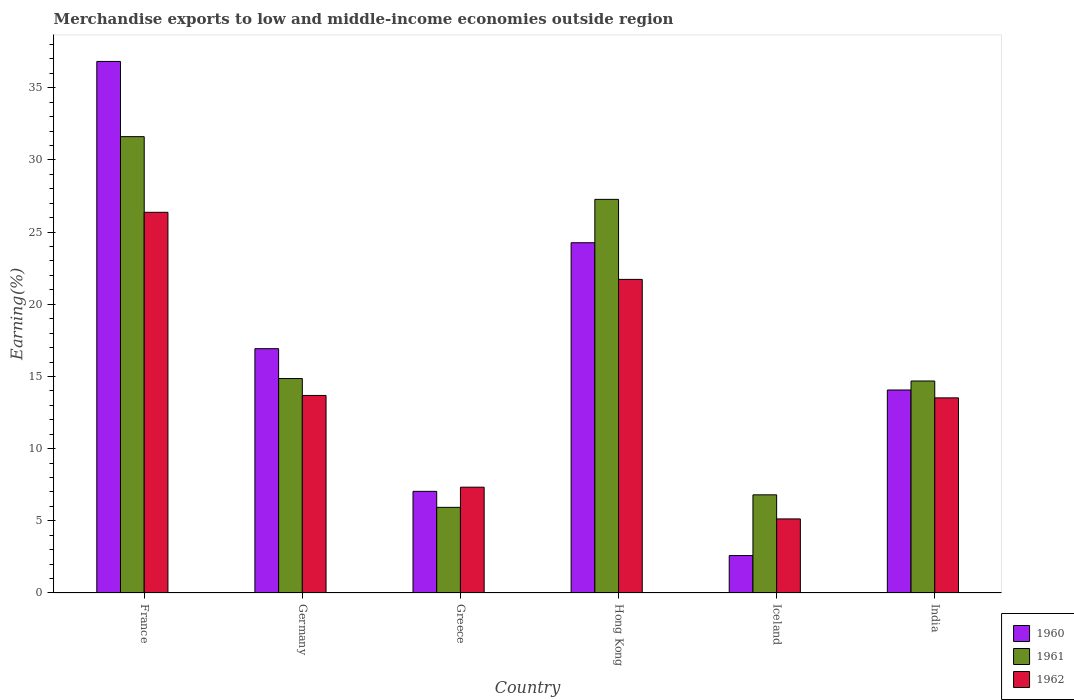How many different coloured bars are there?
Offer a very short reply. 3. How many bars are there on the 2nd tick from the right?
Offer a very short reply. 3. What is the label of the 3rd group of bars from the left?
Provide a short and direct response. Greece. What is the percentage of amount earned from merchandise exports in 1961 in India?
Your answer should be very brief. 14.68. Across all countries, what is the maximum percentage of amount earned from merchandise exports in 1961?
Keep it short and to the point. 31.61. Across all countries, what is the minimum percentage of amount earned from merchandise exports in 1962?
Keep it short and to the point. 5.13. In which country was the percentage of amount earned from merchandise exports in 1960 maximum?
Give a very brief answer. France. In which country was the percentage of amount earned from merchandise exports in 1961 minimum?
Offer a very short reply. Greece. What is the total percentage of amount earned from merchandise exports in 1962 in the graph?
Provide a succinct answer. 87.75. What is the difference between the percentage of amount earned from merchandise exports in 1960 in Iceland and that in India?
Your answer should be compact. -11.47. What is the difference between the percentage of amount earned from merchandise exports in 1960 in Hong Kong and the percentage of amount earned from merchandise exports in 1962 in India?
Give a very brief answer. 10.75. What is the average percentage of amount earned from merchandise exports in 1961 per country?
Offer a terse response. 16.86. What is the difference between the percentage of amount earned from merchandise exports of/in 1961 and percentage of amount earned from merchandise exports of/in 1962 in Hong Kong?
Your answer should be compact. 5.54. What is the ratio of the percentage of amount earned from merchandise exports in 1962 in Germany to that in Greece?
Offer a very short reply. 1.87. Is the percentage of amount earned from merchandise exports in 1962 in Greece less than that in India?
Your answer should be very brief. Yes. Is the difference between the percentage of amount earned from merchandise exports in 1961 in Iceland and India greater than the difference between the percentage of amount earned from merchandise exports in 1962 in Iceland and India?
Provide a succinct answer. Yes. What is the difference between the highest and the second highest percentage of amount earned from merchandise exports in 1962?
Make the answer very short. 12.69. What is the difference between the highest and the lowest percentage of amount earned from merchandise exports in 1960?
Ensure brevity in your answer.  34.23. What does the 2nd bar from the right in Germany represents?
Provide a succinct answer. 1961. Is it the case that in every country, the sum of the percentage of amount earned from merchandise exports in 1961 and percentage of amount earned from merchandise exports in 1962 is greater than the percentage of amount earned from merchandise exports in 1960?
Offer a terse response. Yes. How many countries are there in the graph?
Give a very brief answer. 6. Are the values on the major ticks of Y-axis written in scientific E-notation?
Give a very brief answer. No. Does the graph contain grids?
Provide a short and direct response. No. How many legend labels are there?
Provide a short and direct response. 3. What is the title of the graph?
Your response must be concise. Merchandise exports to low and middle-income economies outside region. Does "1982" appear as one of the legend labels in the graph?
Offer a very short reply. No. What is the label or title of the X-axis?
Provide a succinct answer. Country. What is the label or title of the Y-axis?
Provide a short and direct response. Earning(%). What is the Earning(%) of 1960 in France?
Your response must be concise. 36.82. What is the Earning(%) in 1961 in France?
Your response must be concise. 31.61. What is the Earning(%) of 1962 in France?
Give a very brief answer. 26.37. What is the Earning(%) in 1960 in Germany?
Offer a terse response. 16.92. What is the Earning(%) in 1961 in Germany?
Your answer should be very brief. 14.85. What is the Earning(%) of 1962 in Germany?
Offer a very short reply. 13.68. What is the Earning(%) of 1960 in Greece?
Give a very brief answer. 7.04. What is the Earning(%) of 1961 in Greece?
Offer a terse response. 5.93. What is the Earning(%) in 1962 in Greece?
Provide a short and direct response. 7.33. What is the Earning(%) in 1960 in Hong Kong?
Your response must be concise. 24.26. What is the Earning(%) of 1961 in Hong Kong?
Ensure brevity in your answer.  27.27. What is the Earning(%) of 1962 in Hong Kong?
Ensure brevity in your answer.  21.72. What is the Earning(%) of 1960 in Iceland?
Provide a short and direct response. 2.59. What is the Earning(%) in 1961 in Iceland?
Provide a short and direct response. 6.8. What is the Earning(%) of 1962 in Iceland?
Provide a short and direct response. 5.13. What is the Earning(%) in 1960 in India?
Give a very brief answer. 14.06. What is the Earning(%) in 1961 in India?
Offer a terse response. 14.68. What is the Earning(%) of 1962 in India?
Keep it short and to the point. 13.52. Across all countries, what is the maximum Earning(%) in 1960?
Your response must be concise. 36.82. Across all countries, what is the maximum Earning(%) of 1961?
Your response must be concise. 31.61. Across all countries, what is the maximum Earning(%) of 1962?
Your response must be concise. 26.37. Across all countries, what is the minimum Earning(%) in 1960?
Provide a short and direct response. 2.59. Across all countries, what is the minimum Earning(%) in 1961?
Your response must be concise. 5.93. Across all countries, what is the minimum Earning(%) in 1962?
Your answer should be very brief. 5.13. What is the total Earning(%) in 1960 in the graph?
Keep it short and to the point. 101.7. What is the total Earning(%) in 1961 in the graph?
Provide a short and direct response. 101.15. What is the total Earning(%) of 1962 in the graph?
Your response must be concise. 87.75. What is the difference between the Earning(%) of 1960 in France and that in Germany?
Your answer should be compact. 19.9. What is the difference between the Earning(%) of 1961 in France and that in Germany?
Your answer should be compact. 16.76. What is the difference between the Earning(%) in 1962 in France and that in Germany?
Your answer should be compact. 12.69. What is the difference between the Earning(%) of 1960 in France and that in Greece?
Provide a short and direct response. 29.78. What is the difference between the Earning(%) of 1961 in France and that in Greece?
Offer a very short reply. 25.68. What is the difference between the Earning(%) in 1962 in France and that in Greece?
Provide a short and direct response. 19.04. What is the difference between the Earning(%) of 1960 in France and that in Hong Kong?
Make the answer very short. 12.56. What is the difference between the Earning(%) of 1961 in France and that in Hong Kong?
Provide a short and direct response. 4.34. What is the difference between the Earning(%) of 1962 in France and that in Hong Kong?
Your response must be concise. 4.65. What is the difference between the Earning(%) of 1960 in France and that in Iceland?
Your answer should be very brief. 34.23. What is the difference between the Earning(%) in 1961 in France and that in Iceland?
Provide a succinct answer. 24.81. What is the difference between the Earning(%) in 1962 in France and that in Iceland?
Your answer should be compact. 21.24. What is the difference between the Earning(%) in 1960 in France and that in India?
Provide a succinct answer. 22.76. What is the difference between the Earning(%) in 1961 in France and that in India?
Your response must be concise. 16.93. What is the difference between the Earning(%) in 1962 in France and that in India?
Ensure brevity in your answer.  12.85. What is the difference between the Earning(%) of 1960 in Germany and that in Greece?
Ensure brevity in your answer.  9.88. What is the difference between the Earning(%) in 1961 in Germany and that in Greece?
Make the answer very short. 8.92. What is the difference between the Earning(%) in 1962 in Germany and that in Greece?
Make the answer very short. 6.35. What is the difference between the Earning(%) in 1960 in Germany and that in Hong Kong?
Your response must be concise. -7.34. What is the difference between the Earning(%) of 1961 in Germany and that in Hong Kong?
Ensure brevity in your answer.  -12.41. What is the difference between the Earning(%) in 1962 in Germany and that in Hong Kong?
Offer a very short reply. -8.04. What is the difference between the Earning(%) of 1960 in Germany and that in Iceland?
Ensure brevity in your answer.  14.33. What is the difference between the Earning(%) of 1961 in Germany and that in Iceland?
Keep it short and to the point. 8.05. What is the difference between the Earning(%) in 1962 in Germany and that in Iceland?
Your response must be concise. 8.55. What is the difference between the Earning(%) of 1960 in Germany and that in India?
Provide a succinct answer. 2.86. What is the difference between the Earning(%) in 1961 in Germany and that in India?
Give a very brief answer. 0.17. What is the difference between the Earning(%) of 1962 in Germany and that in India?
Provide a short and direct response. 0.17. What is the difference between the Earning(%) of 1960 in Greece and that in Hong Kong?
Provide a short and direct response. -17.22. What is the difference between the Earning(%) in 1961 in Greece and that in Hong Kong?
Your answer should be compact. -21.33. What is the difference between the Earning(%) of 1962 in Greece and that in Hong Kong?
Provide a succinct answer. -14.39. What is the difference between the Earning(%) in 1960 in Greece and that in Iceland?
Keep it short and to the point. 4.45. What is the difference between the Earning(%) in 1961 in Greece and that in Iceland?
Give a very brief answer. -0.87. What is the difference between the Earning(%) of 1962 in Greece and that in Iceland?
Keep it short and to the point. 2.2. What is the difference between the Earning(%) of 1960 in Greece and that in India?
Your response must be concise. -7.02. What is the difference between the Earning(%) in 1961 in Greece and that in India?
Your answer should be very brief. -8.75. What is the difference between the Earning(%) in 1962 in Greece and that in India?
Keep it short and to the point. -6.19. What is the difference between the Earning(%) in 1960 in Hong Kong and that in Iceland?
Your answer should be compact. 21.67. What is the difference between the Earning(%) of 1961 in Hong Kong and that in Iceland?
Make the answer very short. 20.47. What is the difference between the Earning(%) in 1962 in Hong Kong and that in Iceland?
Offer a terse response. 16.59. What is the difference between the Earning(%) in 1960 in Hong Kong and that in India?
Make the answer very short. 10.2. What is the difference between the Earning(%) in 1961 in Hong Kong and that in India?
Give a very brief answer. 12.58. What is the difference between the Earning(%) of 1962 in Hong Kong and that in India?
Keep it short and to the point. 8.21. What is the difference between the Earning(%) in 1960 in Iceland and that in India?
Keep it short and to the point. -11.47. What is the difference between the Earning(%) of 1961 in Iceland and that in India?
Offer a very short reply. -7.89. What is the difference between the Earning(%) in 1962 in Iceland and that in India?
Offer a terse response. -8.38. What is the difference between the Earning(%) in 1960 in France and the Earning(%) in 1961 in Germany?
Make the answer very short. 21.97. What is the difference between the Earning(%) in 1960 in France and the Earning(%) in 1962 in Germany?
Offer a very short reply. 23.14. What is the difference between the Earning(%) of 1961 in France and the Earning(%) of 1962 in Germany?
Your response must be concise. 17.93. What is the difference between the Earning(%) of 1960 in France and the Earning(%) of 1961 in Greece?
Provide a succinct answer. 30.89. What is the difference between the Earning(%) in 1960 in France and the Earning(%) in 1962 in Greece?
Your response must be concise. 29.49. What is the difference between the Earning(%) of 1961 in France and the Earning(%) of 1962 in Greece?
Provide a short and direct response. 24.28. What is the difference between the Earning(%) of 1960 in France and the Earning(%) of 1961 in Hong Kong?
Make the answer very short. 9.55. What is the difference between the Earning(%) in 1960 in France and the Earning(%) in 1962 in Hong Kong?
Ensure brevity in your answer.  15.1. What is the difference between the Earning(%) in 1961 in France and the Earning(%) in 1962 in Hong Kong?
Make the answer very short. 9.89. What is the difference between the Earning(%) in 1960 in France and the Earning(%) in 1961 in Iceland?
Provide a short and direct response. 30.02. What is the difference between the Earning(%) in 1960 in France and the Earning(%) in 1962 in Iceland?
Keep it short and to the point. 31.69. What is the difference between the Earning(%) in 1961 in France and the Earning(%) in 1962 in Iceland?
Your response must be concise. 26.48. What is the difference between the Earning(%) of 1960 in France and the Earning(%) of 1961 in India?
Offer a terse response. 22.13. What is the difference between the Earning(%) in 1960 in France and the Earning(%) in 1962 in India?
Your answer should be very brief. 23.3. What is the difference between the Earning(%) of 1961 in France and the Earning(%) of 1962 in India?
Your answer should be very brief. 18.09. What is the difference between the Earning(%) in 1960 in Germany and the Earning(%) in 1961 in Greece?
Give a very brief answer. 10.99. What is the difference between the Earning(%) of 1960 in Germany and the Earning(%) of 1962 in Greece?
Give a very brief answer. 9.59. What is the difference between the Earning(%) of 1961 in Germany and the Earning(%) of 1962 in Greece?
Provide a succinct answer. 7.52. What is the difference between the Earning(%) of 1960 in Germany and the Earning(%) of 1961 in Hong Kong?
Ensure brevity in your answer.  -10.34. What is the difference between the Earning(%) in 1960 in Germany and the Earning(%) in 1962 in Hong Kong?
Provide a succinct answer. -4.8. What is the difference between the Earning(%) of 1961 in Germany and the Earning(%) of 1962 in Hong Kong?
Give a very brief answer. -6.87. What is the difference between the Earning(%) of 1960 in Germany and the Earning(%) of 1961 in Iceland?
Provide a short and direct response. 10.12. What is the difference between the Earning(%) in 1960 in Germany and the Earning(%) in 1962 in Iceland?
Provide a short and direct response. 11.79. What is the difference between the Earning(%) in 1961 in Germany and the Earning(%) in 1962 in Iceland?
Make the answer very short. 9.72. What is the difference between the Earning(%) of 1960 in Germany and the Earning(%) of 1961 in India?
Make the answer very short. 2.24. What is the difference between the Earning(%) in 1960 in Germany and the Earning(%) in 1962 in India?
Your answer should be very brief. 3.41. What is the difference between the Earning(%) in 1961 in Germany and the Earning(%) in 1962 in India?
Ensure brevity in your answer.  1.34. What is the difference between the Earning(%) of 1960 in Greece and the Earning(%) of 1961 in Hong Kong?
Your answer should be compact. -20.22. What is the difference between the Earning(%) in 1960 in Greece and the Earning(%) in 1962 in Hong Kong?
Provide a short and direct response. -14.68. What is the difference between the Earning(%) of 1961 in Greece and the Earning(%) of 1962 in Hong Kong?
Provide a short and direct response. -15.79. What is the difference between the Earning(%) in 1960 in Greece and the Earning(%) in 1961 in Iceland?
Your response must be concise. 0.24. What is the difference between the Earning(%) in 1960 in Greece and the Earning(%) in 1962 in Iceland?
Give a very brief answer. 1.91. What is the difference between the Earning(%) in 1961 in Greece and the Earning(%) in 1962 in Iceland?
Ensure brevity in your answer.  0.8. What is the difference between the Earning(%) in 1960 in Greece and the Earning(%) in 1961 in India?
Make the answer very short. -7.64. What is the difference between the Earning(%) of 1960 in Greece and the Earning(%) of 1962 in India?
Give a very brief answer. -6.47. What is the difference between the Earning(%) of 1961 in Greece and the Earning(%) of 1962 in India?
Make the answer very short. -7.58. What is the difference between the Earning(%) in 1960 in Hong Kong and the Earning(%) in 1961 in Iceland?
Your answer should be very brief. 17.46. What is the difference between the Earning(%) of 1960 in Hong Kong and the Earning(%) of 1962 in Iceland?
Your answer should be very brief. 19.13. What is the difference between the Earning(%) in 1961 in Hong Kong and the Earning(%) in 1962 in Iceland?
Make the answer very short. 22.13. What is the difference between the Earning(%) in 1960 in Hong Kong and the Earning(%) in 1961 in India?
Give a very brief answer. 9.58. What is the difference between the Earning(%) of 1960 in Hong Kong and the Earning(%) of 1962 in India?
Provide a short and direct response. 10.75. What is the difference between the Earning(%) in 1961 in Hong Kong and the Earning(%) in 1962 in India?
Ensure brevity in your answer.  13.75. What is the difference between the Earning(%) in 1960 in Iceland and the Earning(%) in 1961 in India?
Offer a terse response. -12.09. What is the difference between the Earning(%) of 1960 in Iceland and the Earning(%) of 1962 in India?
Your answer should be very brief. -10.92. What is the difference between the Earning(%) of 1961 in Iceland and the Earning(%) of 1962 in India?
Your answer should be compact. -6.72. What is the average Earning(%) of 1960 per country?
Provide a short and direct response. 16.95. What is the average Earning(%) in 1961 per country?
Keep it short and to the point. 16.86. What is the average Earning(%) in 1962 per country?
Give a very brief answer. 14.63. What is the difference between the Earning(%) of 1960 and Earning(%) of 1961 in France?
Offer a very short reply. 5.21. What is the difference between the Earning(%) in 1960 and Earning(%) in 1962 in France?
Give a very brief answer. 10.45. What is the difference between the Earning(%) in 1961 and Earning(%) in 1962 in France?
Provide a short and direct response. 5.24. What is the difference between the Earning(%) of 1960 and Earning(%) of 1961 in Germany?
Keep it short and to the point. 2.07. What is the difference between the Earning(%) in 1960 and Earning(%) in 1962 in Germany?
Your response must be concise. 3.24. What is the difference between the Earning(%) in 1961 and Earning(%) in 1962 in Germany?
Give a very brief answer. 1.17. What is the difference between the Earning(%) in 1960 and Earning(%) in 1961 in Greece?
Your answer should be very brief. 1.11. What is the difference between the Earning(%) of 1960 and Earning(%) of 1962 in Greece?
Your answer should be very brief. -0.29. What is the difference between the Earning(%) in 1961 and Earning(%) in 1962 in Greece?
Offer a very short reply. -1.4. What is the difference between the Earning(%) in 1960 and Earning(%) in 1961 in Hong Kong?
Ensure brevity in your answer.  -3. What is the difference between the Earning(%) in 1960 and Earning(%) in 1962 in Hong Kong?
Offer a very short reply. 2.54. What is the difference between the Earning(%) in 1961 and Earning(%) in 1962 in Hong Kong?
Your answer should be compact. 5.54. What is the difference between the Earning(%) of 1960 and Earning(%) of 1961 in Iceland?
Keep it short and to the point. -4.21. What is the difference between the Earning(%) of 1960 and Earning(%) of 1962 in Iceland?
Give a very brief answer. -2.54. What is the difference between the Earning(%) of 1961 and Earning(%) of 1962 in Iceland?
Offer a very short reply. 1.67. What is the difference between the Earning(%) in 1960 and Earning(%) in 1961 in India?
Offer a very short reply. -0.62. What is the difference between the Earning(%) of 1960 and Earning(%) of 1962 in India?
Provide a succinct answer. 0.55. What is the difference between the Earning(%) in 1961 and Earning(%) in 1962 in India?
Provide a succinct answer. 1.17. What is the ratio of the Earning(%) of 1960 in France to that in Germany?
Ensure brevity in your answer.  2.18. What is the ratio of the Earning(%) in 1961 in France to that in Germany?
Ensure brevity in your answer.  2.13. What is the ratio of the Earning(%) in 1962 in France to that in Germany?
Your answer should be very brief. 1.93. What is the ratio of the Earning(%) in 1960 in France to that in Greece?
Provide a succinct answer. 5.23. What is the ratio of the Earning(%) in 1961 in France to that in Greece?
Offer a very short reply. 5.33. What is the ratio of the Earning(%) of 1962 in France to that in Greece?
Provide a short and direct response. 3.6. What is the ratio of the Earning(%) in 1960 in France to that in Hong Kong?
Offer a terse response. 1.52. What is the ratio of the Earning(%) of 1961 in France to that in Hong Kong?
Offer a terse response. 1.16. What is the ratio of the Earning(%) in 1962 in France to that in Hong Kong?
Provide a short and direct response. 1.21. What is the ratio of the Earning(%) in 1960 in France to that in Iceland?
Offer a very short reply. 14.21. What is the ratio of the Earning(%) in 1961 in France to that in Iceland?
Your answer should be very brief. 4.65. What is the ratio of the Earning(%) in 1962 in France to that in Iceland?
Make the answer very short. 5.14. What is the ratio of the Earning(%) of 1960 in France to that in India?
Your response must be concise. 2.62. What is the ratio of the Earning(%) of 1961 in France to that in India?
Provide a short and direct response. 2.15. What is the ratio of the Earning(%) in 1962 in France to that in India?
Make the answer very short. 1.95. What is the ratio of the Earning(%) of 1960 in Germany to that in Greece?
Provide a succinct answer. 2.4. What is the ratio of the Earning(%) in 1961 in Germany to that in Greece?
Provide a short and direct response. 2.5. What is the ratio of the Earning(%) in 1962 in Germany to that in Greece?
Your answer should be very brief. 1.87. What is the ratio of the Earning(%) of 1960 in Germany to that in Hong Kong?
Provide a short and direct response. 0.7. What is the ratio of the Earning(%) of 1961 in Germany to that in Hong Kong?
Provide a succinct answer. 0.54. What is the ratio of the Earning(%) in 1962 in Germany to that in Hong Kong?
Offer a very short reply. 0.63. What is the ratio of the Earning(%) of 1960 in Germany to that in Iceland?
Your answer should be compact. 6.53. What is the ratio of the Earning(%) in 1961 in Germany to that in Iceland?
Keep it short and to the point. 2.18. What is the ratio of the Earning(%) in 1962 in Germany to that in Iceland?
Offer a terse response. 2.67. What is the ratio of the Earning(%) of 1960 in Germany to that in India?
Your answer should be compact. 1.2. What is the ratio of the Earning(%) in 1961 in Germany to that in India?
Ensure brevity in your answer.  1.01. What is the ratio of the Earning(%) of 1962 in Germany to that in India?
Make the answer very short. 1.01. What is the ratio of the Earning(%) in 1960 in Greece to that in Hong Kong?
Your response must be concise. 0.29. What is the ratio of the Earning(%) in 1961 in Greece to that in Hong Kong?
Provide a succinct answer. 0.22. What is the ratio of the Earning(%) in 1962 in Greece to that in Hong Kong?
Your answer should be compact. 0.34. What is the ratio of the Earning(%) in 1960 in Greece to that in Iceland?
Offer a very short reply. 2.72. What is the ratio of the Earning(%) in 1961 in Greece to that in Iceland?
Your answer should be very brief. 0.87. What is the ratio of the Earning(%) of 1962 in Greece to that in Iceland?
Keep it short and to the point. 1.43. What is the ratio of the Earning(%) of 1960 in Greece to that in India?
Offer a terse response. 0.5. What is the ratio of the Earning(%) of 1961 in Greece to that in India?
Offer a very short reply. 0.4. What is the ratio of the Earning(%) in 1962 in Greece to that in India?
Provide a succinct answer. 0.54. What is the ratio of the Earning(%) in 1960 in Hong Kong to that in Iceland?
Your response must be concise. 9.36. What is the ratio of the Earning(%) of 1961 in Hong Kong to that in Iceland?
Provide a short and direct response. 4.01. What is the ratio of the Earning(%) of 1962 in Hong Kong to that in Iceland?
Offer a terse response. 4.23. What is the ratio of the Earning(%) in 1960 in Hong Kong to that in India?
Ensure brevity in your answer.  1.73. What is the ratio of the Earning(%) of 1961 in Hong Kong to that in India?
Provide a succinct answer. 1.86. What is the ratio of the Earning(%) in 1962 in Hong Kong to that in India?
Ensure brevity in your answer.  1.61. What is the ratio of the Earning(%) of 1960 in Iceland to that in India?
Your answer should be compact. 0.18. What is the ratio of the Earning(%) of 1961 in Iceland to that in India?
Provide a succinct answer. 0.46. What is the ratio of the Earning(%) of 1962 in Iceland to that in India?
Provide a short and direct response. 0.38. What is the difference between the highest and the second highest Earning(%) of 1960?
Your response must be concise. 12.56. What is the difference between the highest and the second highest Earning(%) in 1961?
Your answer should be very brief. 4.34. What is the difference between the highest and the second highest Earning(%) of 1962?
Your response must be concise. 4.65. What is the difference between the highest and the lowest Earning(%) of 1960?
Your answer should be very brief. 34.23. What is the difference between the highest and the lowest Earning(%) in 1961?
Keep it short and to the point. 25.68. What is the difference between the highest and the lowest Earning(%) of 1962?
Keep it short and to the point. 21.24. 